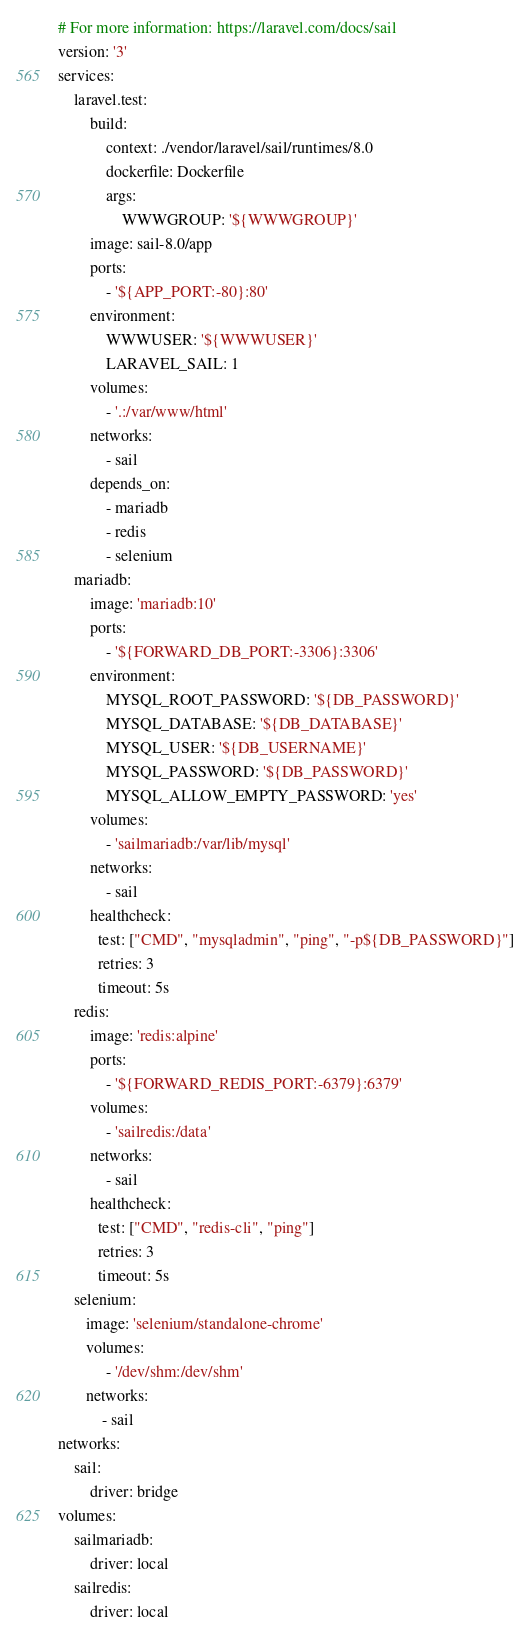<code> <loc_0><loc_0><loc_500><loc_500><_YAML_># For more information: https://laravel.com/docs/sail
version: '3'
services:
    laravel.test:
        build:
            context: ./vendor/laravel/sail/runtimes/8.0
            dockerfile: Dockerfile
            args:
                WWWGROUP: '${WWWGROUP}'
        image: sail-8.0/app
        ports:
            - '${APP_PORT:-80}:80'
        environment:
            WWWUSER: '${WWWUSER}'
            LARAVEL_SAIL: 1
        volumes:
            - '.:/var/www/html'
        networks:
            - sail
        depends_on:
            - mariadb
            - redis
            - selenium
    mariadb:
        image: 'mariadb:10'
        ports:
            - '${FORWARD_DB_PORT:-3306}:3306'
        environment:
            MYSQL_ROOT_PASSWORD: '${DB_PASSWORD}'
            MYSQL_DATABASE: '${DB_DATABASE}'
            MYSQL_USER: '${DB_USERNAME}'
            MYSQL_PASSWORD: '${DB_PASSWORD}'
            MYSQL_ALLOW_EMPTY_PASSWORD: 'yes'
        volumes:
            - 'sailmariadb:/var/lib/mysql'
        networks:
            - sail
        healthcheck:
          test: ["CMD", "mysqladmin", "ping", "-p${DB_PASSWORD}"]
          retries: 3
          timeout: 5s
    redis:
        image: 'redis:alpine'
        ports:
            - '${FORWARD_REDIS_PORT:-6379}:6379'
        volumes:
            - 'sailredis:/data'
        networks:
            - sail
        healthcheck:
          test: ["CMD", "redis-cli", "ping"]
          retries: 3
          timeout: 5s
    selenium:
       image: 'selenium/standalone-chrome'
       volumes:
            - '/dev/shm:/dev/shm'
       networks:
           - sail
networks:
    sail:
        driver: bridge
volumes:
    sailmariadb:
        driver: local
    sailredis:
        driver: local
</code> 